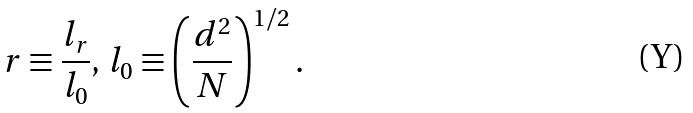<formula> <loc_0><loc_0><loc_500><loc_500>r \equiv \frac { l _ { r } } { l _ { 0 } } , \, l _ { 0 } \equiv \left ( \frac { d ^ { 2 } } { N } \right ) ^ { 1 / 2 } .</formula> 